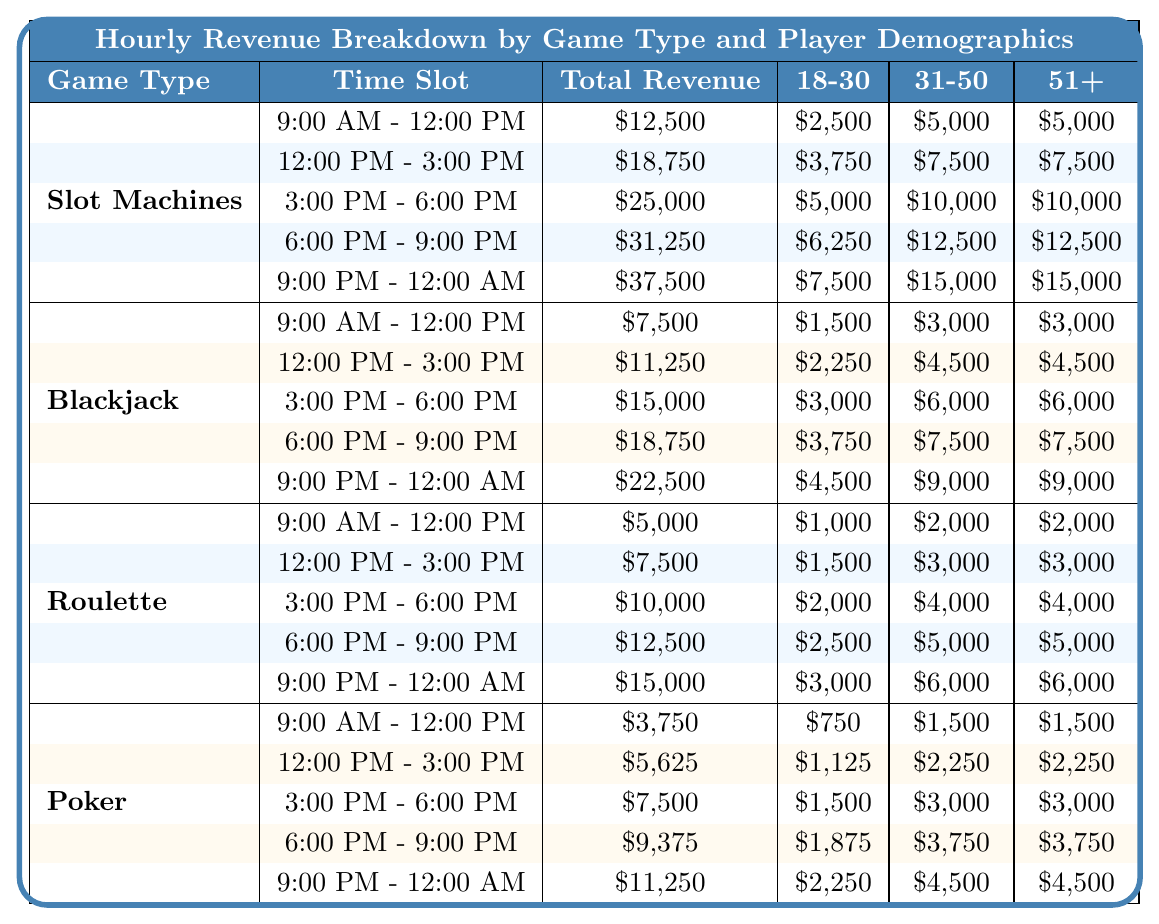What is the total revenue from Slot Machines between 3:00 PM and 6:00 PM? According to the table, the revenue for Slot Machines during that time slot is $25,000.
Answer: $25,000 What is the total revenue generated by Blackjack from 12:00 PM to 3:00 PM? The table indicates that Blackjack generated $11,250 in revenue for that time period.
Answer: $11,250 Which game type generated the highest revenue between 6:00 PM and 9:00 PM? The table shows Slot Machines generated $31,250, which is higher than Blackjack's $18,750, Roulette's $12,500, and Poker's $9,375.
Answer: Slot Machines What percentage of the total revenue from Roulette comes from players aged 31-50 during the 9:00 PM - 12:00 AM time slot? Roulette generated $15,000 in total revenue for that period, with $6,000 coming from players aged 31-50. To find the percentage, calculate (6,000 / 15,000) * 100 = 40%.
Answer: 40% What is the combined revenue from all games during the time slot of 9:00 AM - 12:00 PM? Slot Machines generated $12,500, Blackjack $7,500, Roulette $5,000, and Poker $3,750. Summing these gives $12,500 + $7,500 + $5,000 + $3,750 = $28,750.
Answer: $28,750 Is the revenue generated by players aged 18-30 in Slot Machines higher than that of Blackjack for the 12:00 PM - 3:00 PM time slot? Slot Machines generated $3,750 from 18-30 players, while Blackjack generated $2,250 in the same time slot, thus Slot Machines generated more.
Answer: Yes Which time slot generated the highest revenue for Poker? The table shows that between 9:00 PM and 12:00 AM, Poker generated $11,250, which is higher than its revenues in other time slots.
Answer: 9:00 PM - 12:00 AM If we compare the revenue from 18-30 players across all game types during 6:00 PM to 9:00 PM, which game type has the maximum revenue? For that time slot, Slot Machines had $6,250, Blackjack $3,750, Roulette $2,500, and Poker $1,875. The highest is $6,250 from Slot Machines.
Answer: Slot Machines What is the discrepancy in revenue from players aged 51+ between Slot Machines and Poker during the time slot of 12:00 PM - 3:00 PM? Slot Machines had $7,500 from players aged 51+, while Poker had $2,250, so the discrepancy is $7,500 - $2,250 = $5,250.
Answer: $5,250 What is the average revenue per hour for Blackjack? Blackjack total revenue for all time slots is $7,500 + $11,250 + $15,000 + $18,750 + $22,500 = $75,000. There are 5 time slots, so the average revenue per hour is $75,000 / 5 = $15,000.
Answer: $15,000 